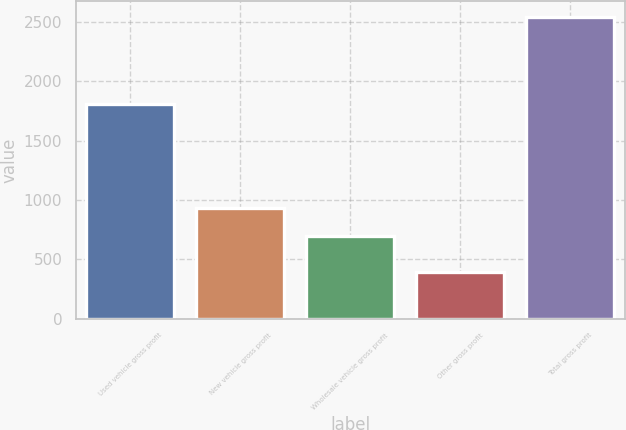<chart> <loc_0><loc_0><loc_500><loc_500><bar_chart><fcel>Used vehicle gross profit<fcel>New vehicle gross profit<fcel>Wholesale vehicle gross profit<fcel>Other gross profit<fcel>Total gross profit<nl><fcel>1808<fcel>934<fcel>700<fcel>391<fcel>2544<nl></chart> 